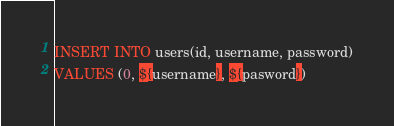<code> <loc_0><loc_0><loc_500><loc_500><_SQL_>INSERT INTO users(id, username, password)
VALUES (0, ${username}, ${pasword})</code> 